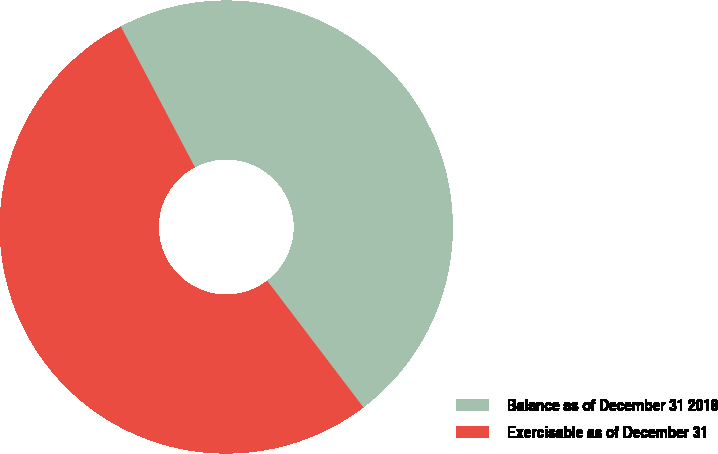<chart> <loc_0><loc_0><loc_500><loc_500><pie_chart><fcel>Balance as of December 31 2018<fcel>Exercisable as of December 31<nl><fcel>47.37%<fcel>52.63%<nl></chart> 